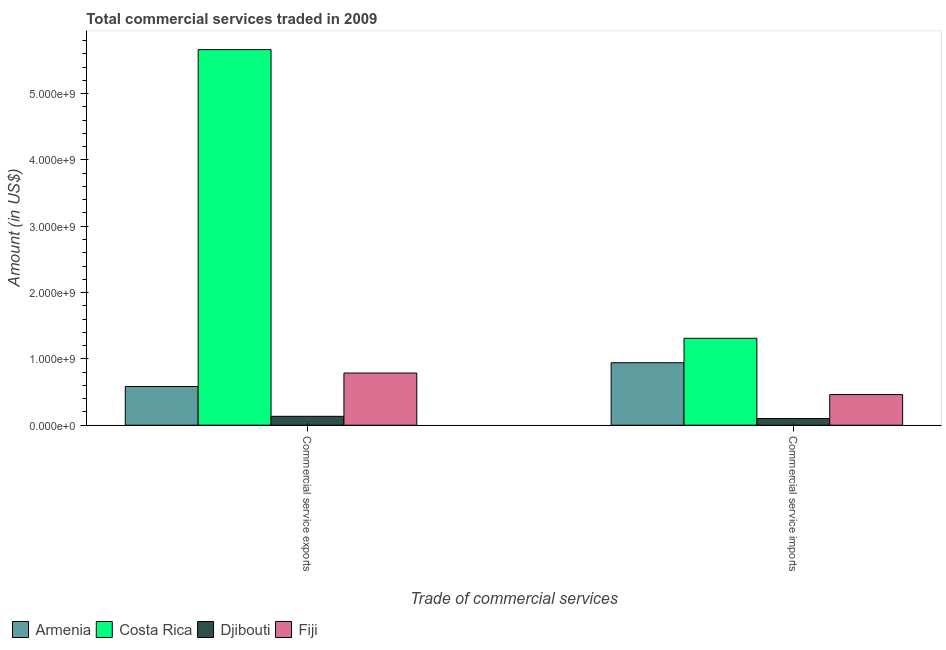Are the number of bars per tick equal to the number of legend labels?
Provide a succinct answer. Yes. How many bars are there on the 2nd tick from the left?
Ensure brevity in your answer.  4. How many bars are there on the 1st tick from the right?
Offer a very short reply. 4. What is the label of the 2nd group of bars from the left?
Provide a short and direct response. Commercial service imports. What is the amount of commercial service imports in Armenia?
Provide a short and direct response. 9.42e+08. Across all countries, what is the maximum amount of commercial service exports?
Make the answer very short. 5.66e+09. Across all countries, what is the minimum amount of commercial service imports?
Give a very brief answer. 1.00e+08. In which country was the amount of commercial service imports maximum?
Ensure brevity in your answer.  Costa Rica. In which country was the amount of commercial service exports minimum?
Offer a very short reply. Djibouti. What is the total amount of commercial service exports in the graph?
Provide a succinct answer. 7.17e+09. What is the difference between the amount of commercial service exports in Costa Rica and that in Djibouti?
Provide a succinct answer. 5.53e+09. What is the difference between the amount of commercial service exports in Armenia and the amount of commercial service imports in Fiji?
Ensure brevity in your answer.  1.21e+08. What is the average amount of commercial service imports per country?
Provide a short and direct response. 7.04e+08. What is the difference between the amount of commercial service imports and amount of commercial service exports in Fiji?
Your answer should be compact. -3.24e+08. In how many countries, is the amount of commercial service imports greater than 400000000 US$?
Ensure brevity in your answer.  3. What is the ratio of the amount of commercial service exports in Armenia to that in Fiji?
Keep it short and to the point. 0.74. In how many countries, is the amount of commercial service imports greater than the average amount of commercial service imports taken over all countries?
Make the answer very short. 2. What does the 3rd bar from the left in Commercial service exports represents?
Provide a succinct answer. Djibouti. What does the 3rd bar from the right in Commercial service imports represents?
Make the answer very short. Costa Rica. How many bars are there?
Ensure brevity in your answer.  8. Are the values on the major ticks of Y-axis written in scientific E-notation?
Offer a very short reply. Yes. Does the graph contain any zero values?
Ensure brevity in your answer.  No. Does the graph contain grids?
Your answer should be compact. No. How many legend labels are there?
Your answer should be compact. 4. How are the legend labels stacked?
Your response must be concise. Horizontal. What is the title of the graph?
Your answer should be very brief. Total commercial services traded in 2009. What is the label or title of the X-axis?
Provide a short and direct response. Trade of commercial services. What is the Amount (in US$) of Armenia in Commercial service exports?
Make the answer very short. 5.83e+08. What is the Amount (in US$) in Costa Rica in Commercial service exports?
Offer a terse response. 5.66e+09. What is the Amount (in US$) of Djibouti in Commercial service exports?
Keep it short and to the point. 1.34e+08. What is the Amount (in US$) of Fiji in Commercial service exports?
Offer a very short reply. 7.86e+08. What is the Amount (in US$) of Armenia in Commercial service imports?
Give a very brief answer. 9.42e+08. What is the Amount (in US$) in Costa Rica in Commercial service imports?
Give a very brief answer. 1.31e+09. What is the Amount (in US$) of Djibouti in Commercial service imports?
Provide a succinct answer. 1.00e+08. What is the Amount (in US$) in Fiji in Commercial service imports?
Keep it short and to the point. 4.62e+08. Across all Trade of commercial services, what is the maximum Amount (in US$) of Armenia?
Give a very brief answer. 9.42e+08. Across all Trade of commercial services, what is the maximum Amount (in US$) of Costa Rica?
Make the answer very short. 5.66e+09. Across all Trade of commercial services, what is the maximum Amount (in US$) in Djibouti?
Your answer should be very brief. 1.34e+08. Across all Trade of commercial services, what is the maximum Amount (in US$) in Fiji?
Keep it short and to the point. 7.86e+08. Across all Trade of commercial services, what is the minimum Amount (in US$) in Armenia?
Keep it short and to the point. 5.83e+08. Across all Trade of commercial services, what is the minimum Amount (in US$) in Costa Rica?
Make the answer very short. 1.31e+09. Across all Trade of commercial services, what is the minimum Amount (in US$) of Djibouti?
Provide a short and direct response. 1.00e+08. Across all Trade of commercial services, what is the minimum Amount (in US$) of Fiji?
Offer a very short reply. 4.62e+08. What is the total Amount (in US$) of Armenia in the graph?
Ensure brevity in your answer.  1.53e+09. What is the total Amount (in US$) of Costa Rica in the graph?
Your answer should be very brief. 6.97e+09. What is the total Amount (in US$) in Djibouti in the graph?
Offer a very short reply. 2.34e+08. What is the total Amount (in US$) in Fiji in the graph?
Your answer should be compact. 1.25e+09. What is the difference between the Amount (in US$) of Armenia in Commercial service exports and that in Commercial service imports?
Offer a very short reply. -3.59e+08. What is the difference between the Amount (in US$) in Costa Rica in Commercial service exports and that in Commercial service imports?
Give a very brief answer. 4.35e+09. What is the difference between the Amount (in US$) in Djibouti in Commercial service exports and that in Commercial service imports?
Make the answer very short. 3.34e+07. What is the difference between the Amount (in US$) of Fiji in Commercial service exports and that in Commercial service imports?
Your answer should be compact. 3.24e+08. What is the difference between the Amount (in US$) in Armenia in Commercial service exports and the Amount (in US$) in Costa Rica in Commercial service imports?
Give a very brief answer. -7.27e+08. What is the difference between the Amount (in US$) in Armenia in Commercial service exports and the Amount (in US$) in Djibouti in Commercial service imports?
Your answer should be very brief. 4.83e+08. What is the difference between the Amount (in US$) of Armenia in Commercial service exports and the Amount (in US$) of Fiji in Commercial service imports?
Offer a terse response. 1.21e+08. What is the difference between the Amount (in US$) of Costa Rica in Commercial service exports and the Amount (in US$) of Djibouti in Commercial service imports?
Keep it short and to the point. 5.56e+09. What is the difference between the Amount (in US$) in Costa Rica in Commercial service exports and the Amount (in US$) in Fiji in Commercial service imports?
Your answer should be compact. 5.20e+09. What is the difference between the Amount (in US$) of Djibouti in Commercial service exports and the Amount (in US$) of Fiji in Commercial service imports?
Your answer should be very brief. -3.28e+08. What is the average Amount (in US$) of Armenia per Trade of commercial services?
Give a very brief answer. 7.63e+08. What is the average Amount (in US$) in Costa Rica per Trade of commercial services?
Provide a short and direct response. 3.49e+09. What is the average Amount (in US$) in Djibouti per Trade of commercial services?
Your answer should be very brief. 1.17e+08. What is the average Amount (in US$) in Fiji per Trade of commercial services?
Give a very brief answer. 6.24e+08. What is the difference between the Amount (in US$) in Armenia and Amount (in US$) in Costa Rica in Commercial service exports?
Your answer should be very brief. -5.08e+09. What is the difference between the Amount (in US$) in Armenia and Amount (in US$) in Djibouti in Commercial service exports?
Keep it short and to the point. 4.49e+08. What is the difference between the Amount (in US$) of Armenia and Amount (in US$) of Fiji in Commercial service exports?
Give a very brief answer. -2.03e+08. What is the difference between the Amount (in US$) in Costa Rica and Amount (in US$) in Djibouti in Commercial service exports?
Your answer should be compact. 5.53e+09. What is the difference between the Amount (in US$) of Costa Rica and Amount (in US$) of Fiji in Commercial service exports?
Provide a short and direct response. 4.88e+09. What is the difference between the Amount (in US$) of Djibouti and Amount (in US$) of Fiji in Commercial service exports?
Offer a very short reply. -6.52e+08. What is the difference between the Amount (in US$) of Armenia and Amount (in US$) of Costa Rica in Commercial service imports?
Give a very brief answer. -3.68e+08. What is the difference between the Amount (in US$) in Armenia and Amount (in US$) in Djibouti in Commercial service imports?
Make the answer very short. 8.42e+08. What is the difference between the Amount (in US$) of Armenia and Amount (in US$) of Fiji in Commercial service imports?
Ensure brevity in your answer.  4.80e+08. What is the difference between the Amount (in US$) of Costa Rica and Amount (in US$) of Djibouti in Commercial service imports?
Offer a terse response. 1.21e+09. What is the difference between the Amount (in US$) in Costa Rica and Amount (in US$) in Fiji in Commercial service imports?
Your answer should be compact. 8.48e+08. What is the difference between the Amount (in US$) in Djibouti and Amount (in US$) in Fiji in Commercial service imports?
Keep it short and to the point. -3.61e+08. What is the ratio of the Amount (in US$) in Armenia in Commercial service exports to that in Commercial service imports?
Offer a terse response. 0.62. What is the ratio of the Amount (in US$) of Costa Rica in Commercial service exports to that in Commercial service imports?
Ensure brevity in your answer.  4.32. What is the ratio of the Amount (in US$) in Djibouti in Commercial service exports to that in Commercial service imports?
Your answer should be compact. 1.33. What is the ratio of the Amount (in US$) of Fiji in Commercial service exports to that in Commercial service imports?
Your response must be concise. 1.7. What is the difference between the highest and the second highest Amount (in US$) in Armenia?
Your response must be concise. 3.59e+08. What is the difference between the highest and the second highest Amount (in US$) of Costa Rica?
Provide a succinct answer. 4.35e+09. What is the difference between the highest and the second highest Amount (in US$) in Djibouti?
Offer a terse response. 3.34e+07. What is the difference between the highest and the second highest Amount (in US$) of Fiji?
Your answer should be very brief. 3.24e+08. What is the difference between the highest and the lowest Amount (in US$) in Armenia?
Your answer should be very brief. 3.59e+08. What is the difference between the highest and the lowest Amount (in US$) in Costa Rica?
Keep it short and to the point. 4.35e+09. What is the difference between the highest and the lowest Amount (in US$) in Djibouti?
Provide a short and direct response. 3.34e+07. What is the difference between the highest and the lowest Amount (in US$) in Fiji?
Your response must be concise. 3.24e+08. 